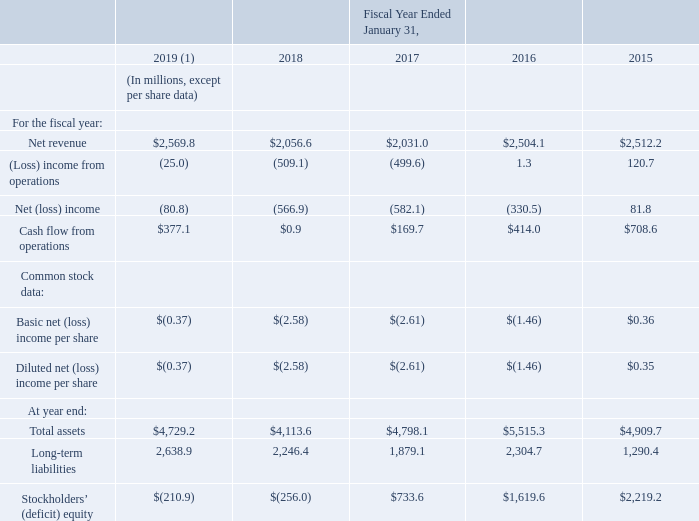ITEM 6. SELECTED FINANCIAL DATA
The following selected consolidated financial data is not necessarily indicative of results of future operations, and should be read in conjunction with Item 7, “Management's Discussion and Analysis of Financial Condition and Results of Operations,” and the consolidated financial statements and related notes thereto included in Item 8 of this Form 10-K to fully understand factors that may affect the comparability of the information presented below.
The financial data for the fiscal years ended January 31, 2019 and 2018 are derived from, and are qualified by reference to, the audited consolidated financial statements that are included in this Form 10-K. The Consolidated Statements of Operations and the Consolidated Statements of Cash Flows data for the fiscal year ended January 31, 2017 are derived from, and are qualified by reference to, the audited consolidated financial statements that are included in this Form 10-K. The Consolidated Balance Sheet data for the fiscal year ended January 31, 2017 and the remaining financial data for the fiscal years ended January 31, 2016 and 2015 are derived from audited, consolidated financial statements which are not included in this Form 10-K.
(1) Reflects the impact of the adoption of new accounting standards in fiscal year 2019 related to revenue recognition. See Part II, Item 8, Note 1, Business and Summary of Significant Accounting Policies, Accounting Standards Adopted, of our consolidated financial statements for additional information.
What was the cash flow from operations in 2019?
Answer scale should be: million. $377.1. What was the company's total liabilities in 2018?
Answer scale should be: million. 4,113.6- (-256) 
Answer: 4369.6. What is the year-on-year percentage change in cash flow from operations from 2018 to 2019?
Answer scale should be: percent. (377.1-0.9)/0.9  
Answer: 41800. What other statements or information should be read together with the financial table? Item 7, “management's discussion and analysis of financial condition and results of operations,” and the consolidated financial statements and related notes thereto included in item 8 of this form 10-k. What is the net revenue for the fiscal year 2017?
Answer scale should be: million. $2,031.0. What is the average net income from 2015 to 2019?
Answer scale should be: million. $(-80.8-566.9-582.1-330.5+81.8)/5 
Answer: -295.7. 